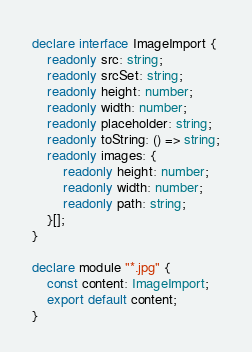Convert code to text. <code><loc_0><loc_0><loc_500><loc_500><_TypeScript_>declare interface ImageImport {
    readonly src: string;
    readonly srcSet: string;
    readonly height: number;
    readonly width: number;
    readonly placeholder: string;
    readonly toString: () => string;
    readonly images: {
        readonly height: number;
        readonly width: number;
        readonly path: string;
    }[];
}

declare module "*.jpg" {
    const content: ImageImport;
    export default content;
}
</code> 